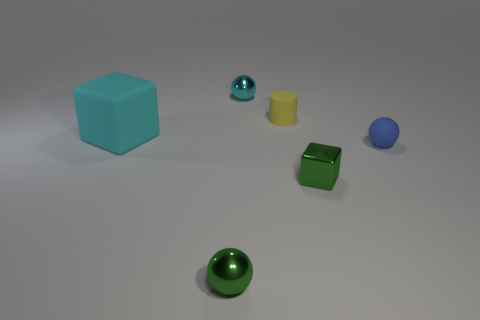Subtract all tiny blue rubber spheres. How many spheres are left? 2 Add 1 small rubber balls. How many objects exist? 7 Subtract all green cubes. How many cubes are left? 1 Subtract 0 gray cylinders. How many objects are left? 6 Subtract all blocks. How many objects are left? 4 Subtract 2 spheres. How many spheres are left? 1 Subtract all gray cubes. Subtract all red balls. How many cubes are left? 2 Subtract all gray balls. How many cyan cubes are left? 1 Subtract all red blocks. Subtract all green spheres. How many objects are left? 5 Add 2 shiny spheres. How many shiny spheres are left? 4 